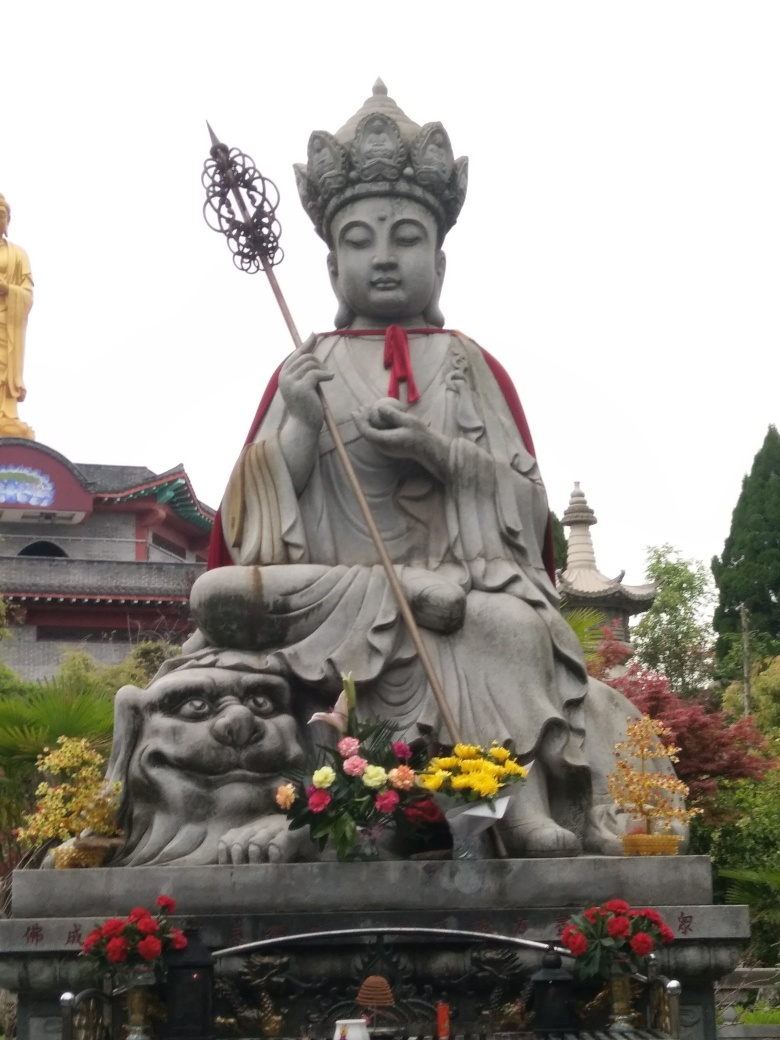Is the main subject clear in the image?
A. Fairly clear
B. Slightly blurry
C. Completely unclear
D. Very blurry
Answer with the option's letter from the given choices directly.
 A. 